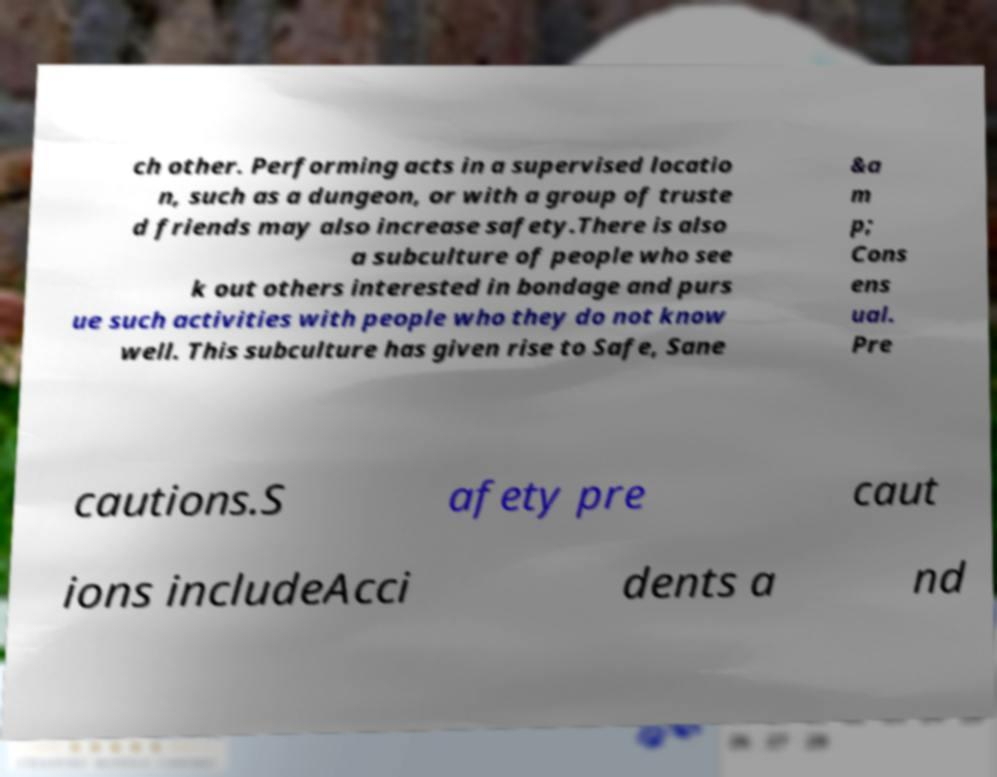For documentation purposes, I need the text within this image transcribed. Could you provide that? ch other. Performing acts in a supervised locatio n, such as a dungeon, or with a group of truste d friends may also increase safety.There is also a subculture of people who see k out others interested in bondage and purs ue such activities with people who they do not know well. This subculture has given rise to Safe, Sane &a m p; Cons ens ual. Pre cautions.S afety pre caut ions includeAcci dents a nd 